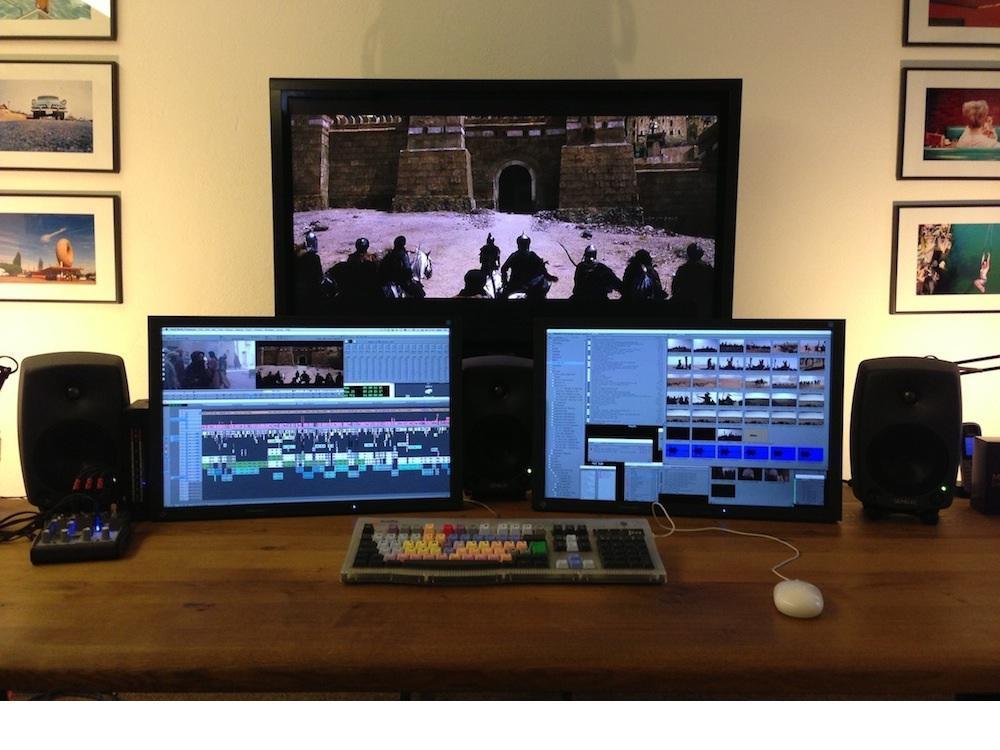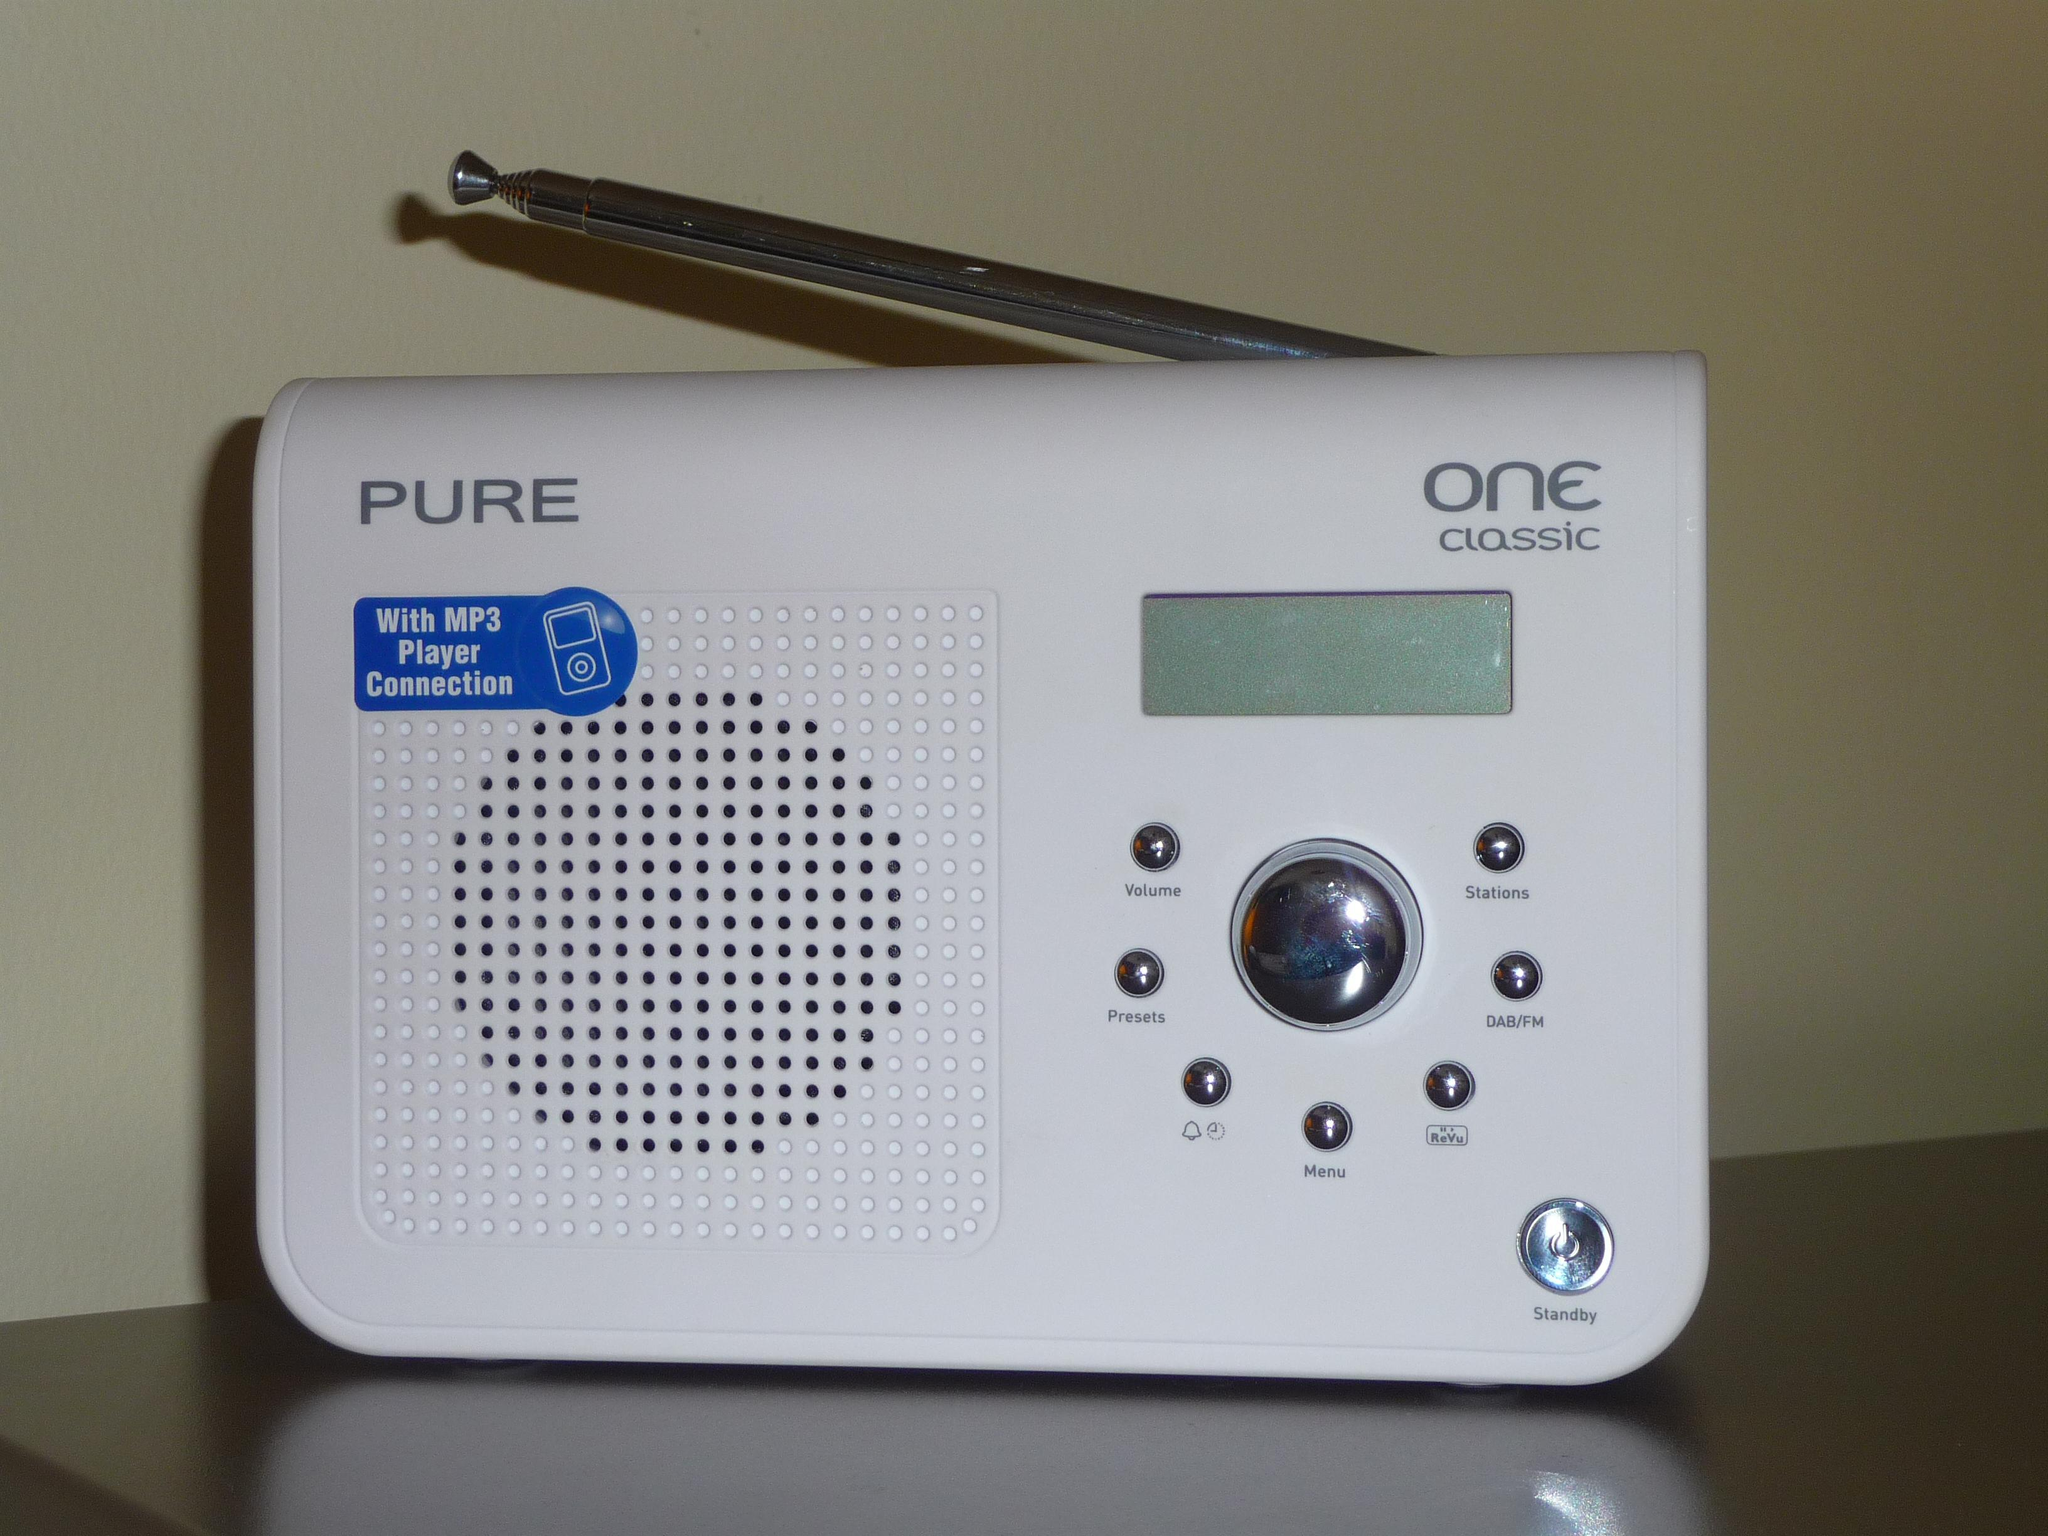The first image is the image on the left, the second image is the image on the right. Evaluate the accuracy of this statement regarding the images: "The right image contains  television with an antenna.". Is it true? Answer yes or no. No. The first image is the image on the left, the second image is the image on the right. For the images displayed, is the sentence "The right image shows one pale-colored device with an antenna angled leftward and a grid of dots on its front." factually correct? Answer yes or no. Yes. 